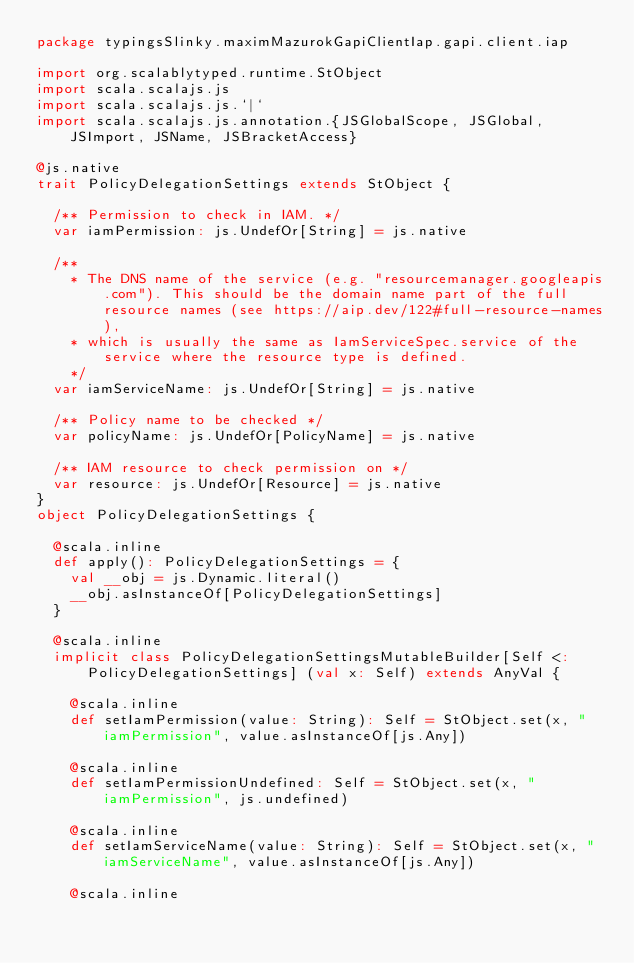<code> <loc_0><loc_0><loc_500><loc_500><_Scala_>package typingsSlinky.maximMazurokGapiClientIap.gapi.client.iap

import org.scalablytyped.runtime.StObject
import scala.scalajs.js
import scala.scalajs.js.`|`
import scala.scalajs.js.annotation.{JSGlobalScope, JSGlobal, JSImport, JSName, JSBracketAccess}

@js.native
trait PolicyDelegationSettings extends StObject {
  
  /** Permission to check in IAM. */
  var iamPermission: js.UndefOr[String] = js.native
  
  /**
    * The DNS name of the service (e.g. "resourcemanager.googleapis.com"). This should be the domain name part of the full resource names (see https://aip.dev/122#full-resource-names),
    * which is usually the same as IamServiceSpec.service of the service where the resource type is defined.
    */
  var iamServiceName: js.UndefOr[String] = js.native
  
  /** Policy name to be checked */
  var policyName: js.UndefOr[PolicyName] = js.native
  
  /** IAM resource to check permission on */
  var resource: js.UndefOr[Resource] = js.native
}
object PolicyDelegationSettings {
  
  @scala.inline
  def apply(): PolicyDelegationSettings = {
    val __obj = js.Dynamic.literal()
    __obj.asInstanceOf[PolicyDelegationSettings]
  }
  
  @scala.inline
  implicit class PolicyDelegationSettingsMutableBuilder[Self <: PolicyDelegationSettings] (val x: Self) extends AnyVal {
    
    @scala.inline
    def setIamPermission(value: String): Self = StObject.set(x, "iamPermission", value.asInstanceOf[js.Any])
    
    @scala.inline
    def setIamPermissionUndefined: Self = StObject.set(x, "iamPermission", js.undefined)
    
    @scala.inline
    def setIamServiceName(value: String): Self = StObject.set(x, "iamServiceName", value.asInstanceOf[js.Any])
    
    @scala.inline</code> 